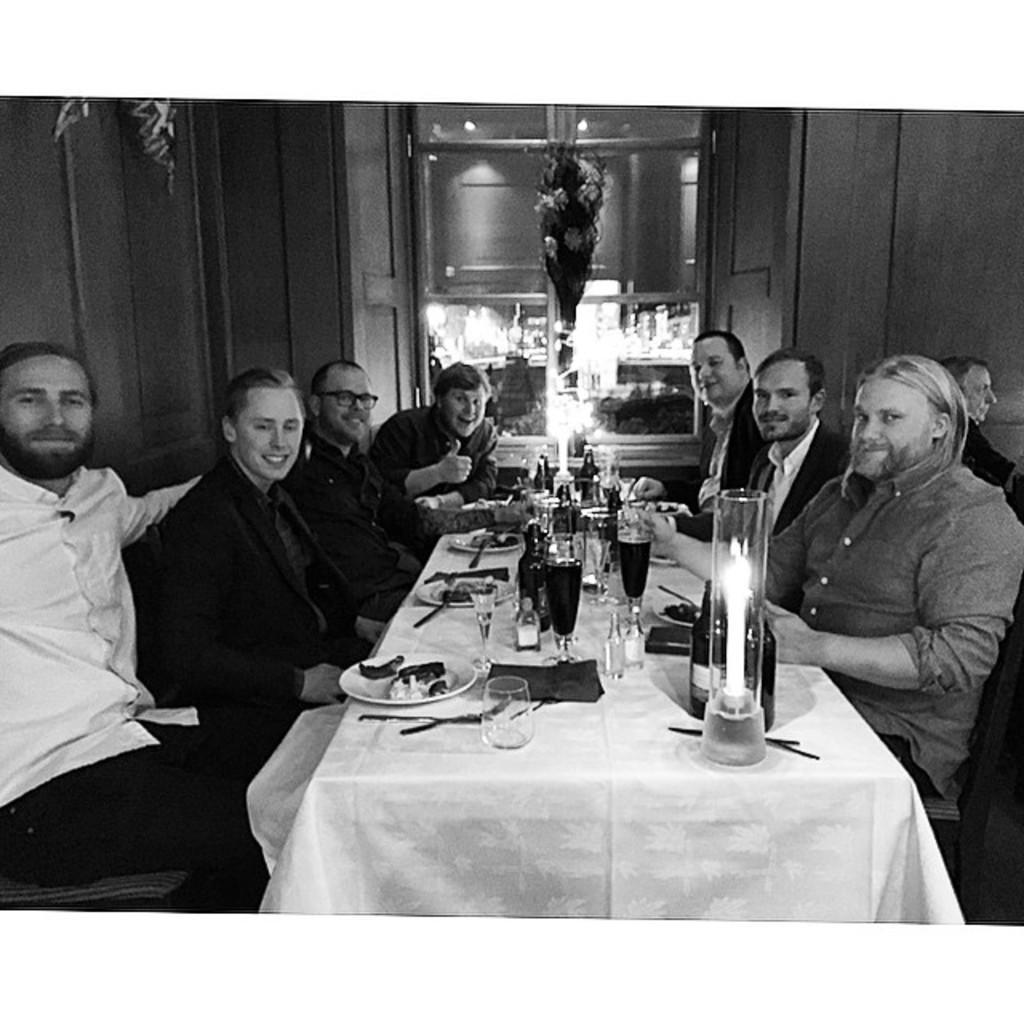In one or two sentences, can you explain what this image depicts? This picture shows a group of people seated on the chairs and we see few plates ,spoons and wine glasses and a candle on the table 